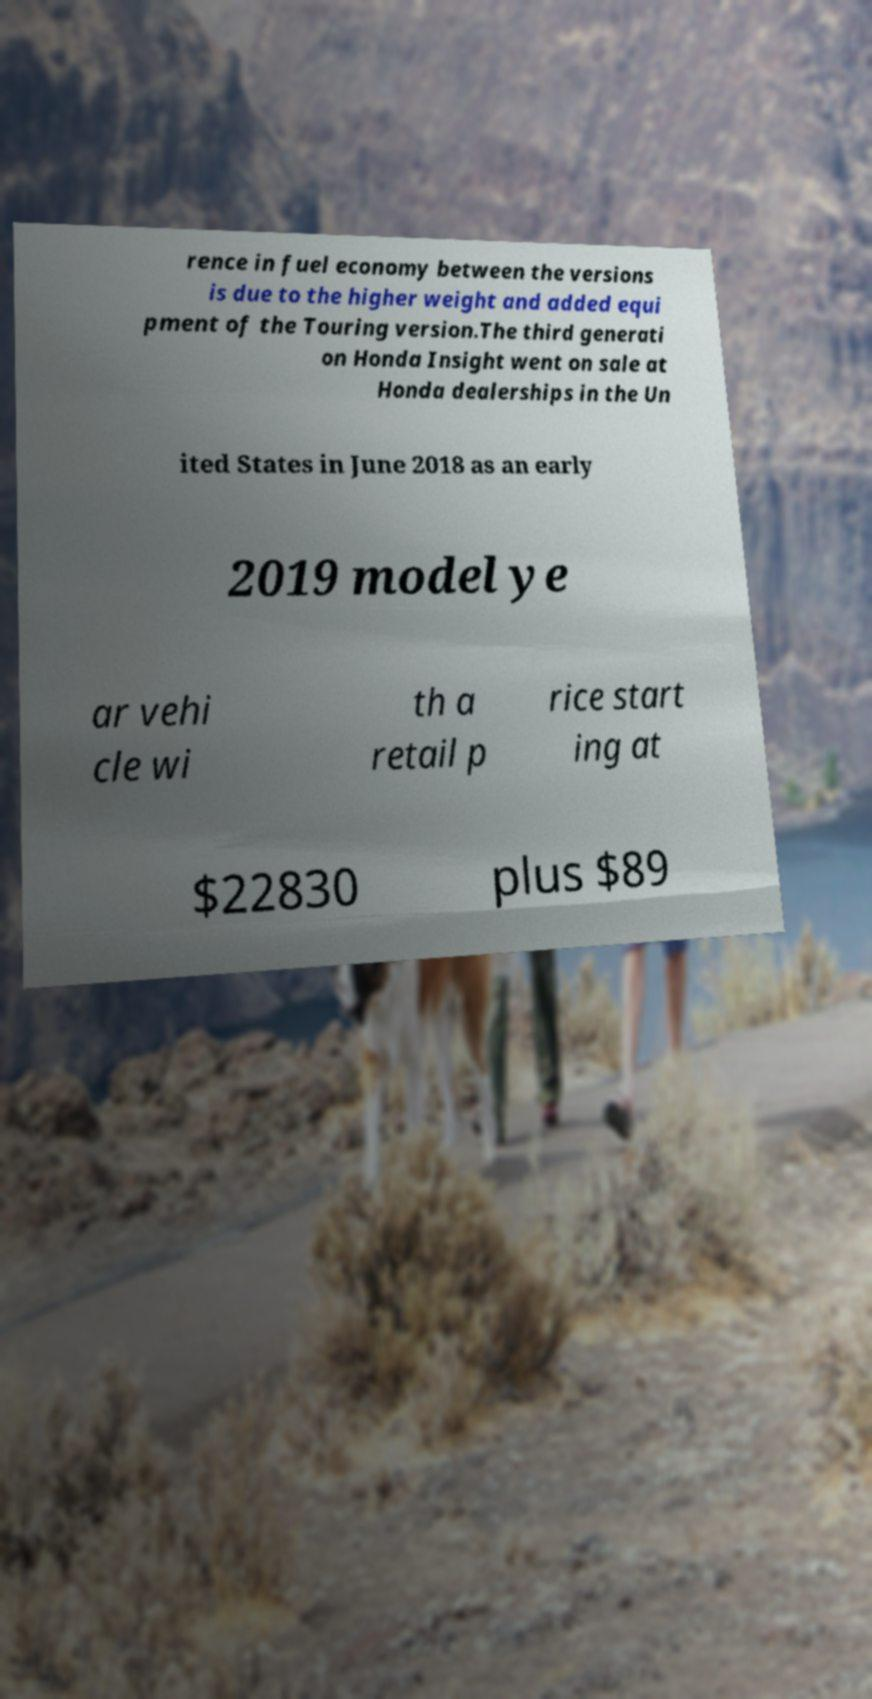Can you read and provide the text displayed in the image?This photo seems to have some interesting text. Can you extract and type it out for me? rence in fuel economy between the versions is due to the higher weight and added equi pment of the Touring version.The third generati on Honda Insight went on sale at Honda dealerships in the Un ited States in June 2018 as an early 2019 model ye ar vehi cle wi th a retail p rice start ing at $22830 plus $89 